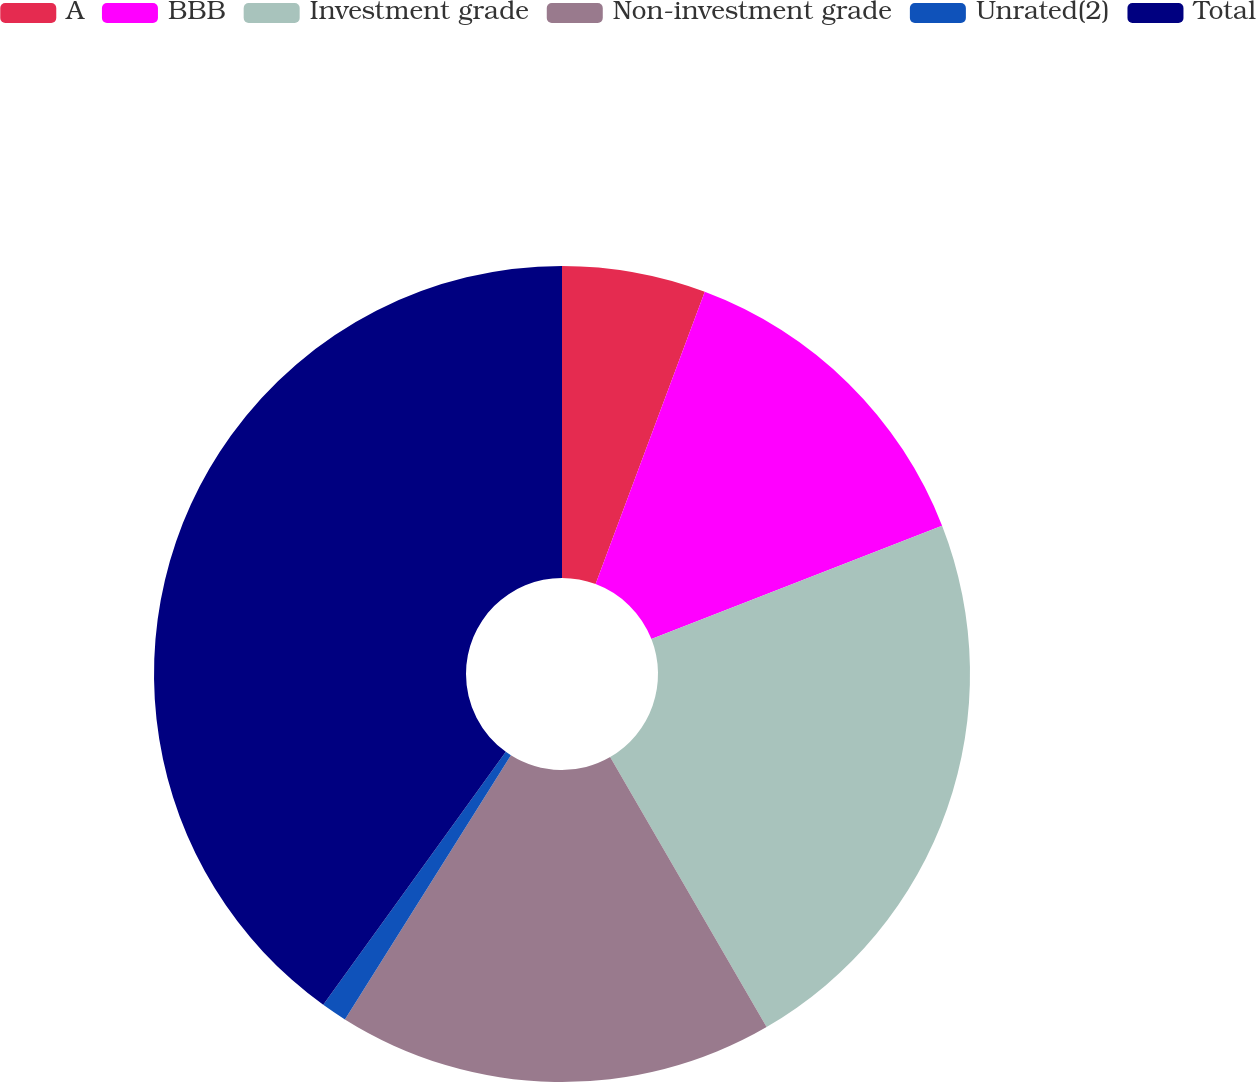Convert chart to OTSL. <chart><loc_0><loc_0><loc_500><loc_500><pie_chart><fcel>A<fcel>BBB<fcel>Investment grade<fcel>Non-investment grade<fcel>Unrated(2)<fcel>Total<nl><fcel>5.69%<fcel>13.39%<fcel>22.56%<fcel>17.29%<fcel>1.02%<fcel>40.05%<nl></chart> 